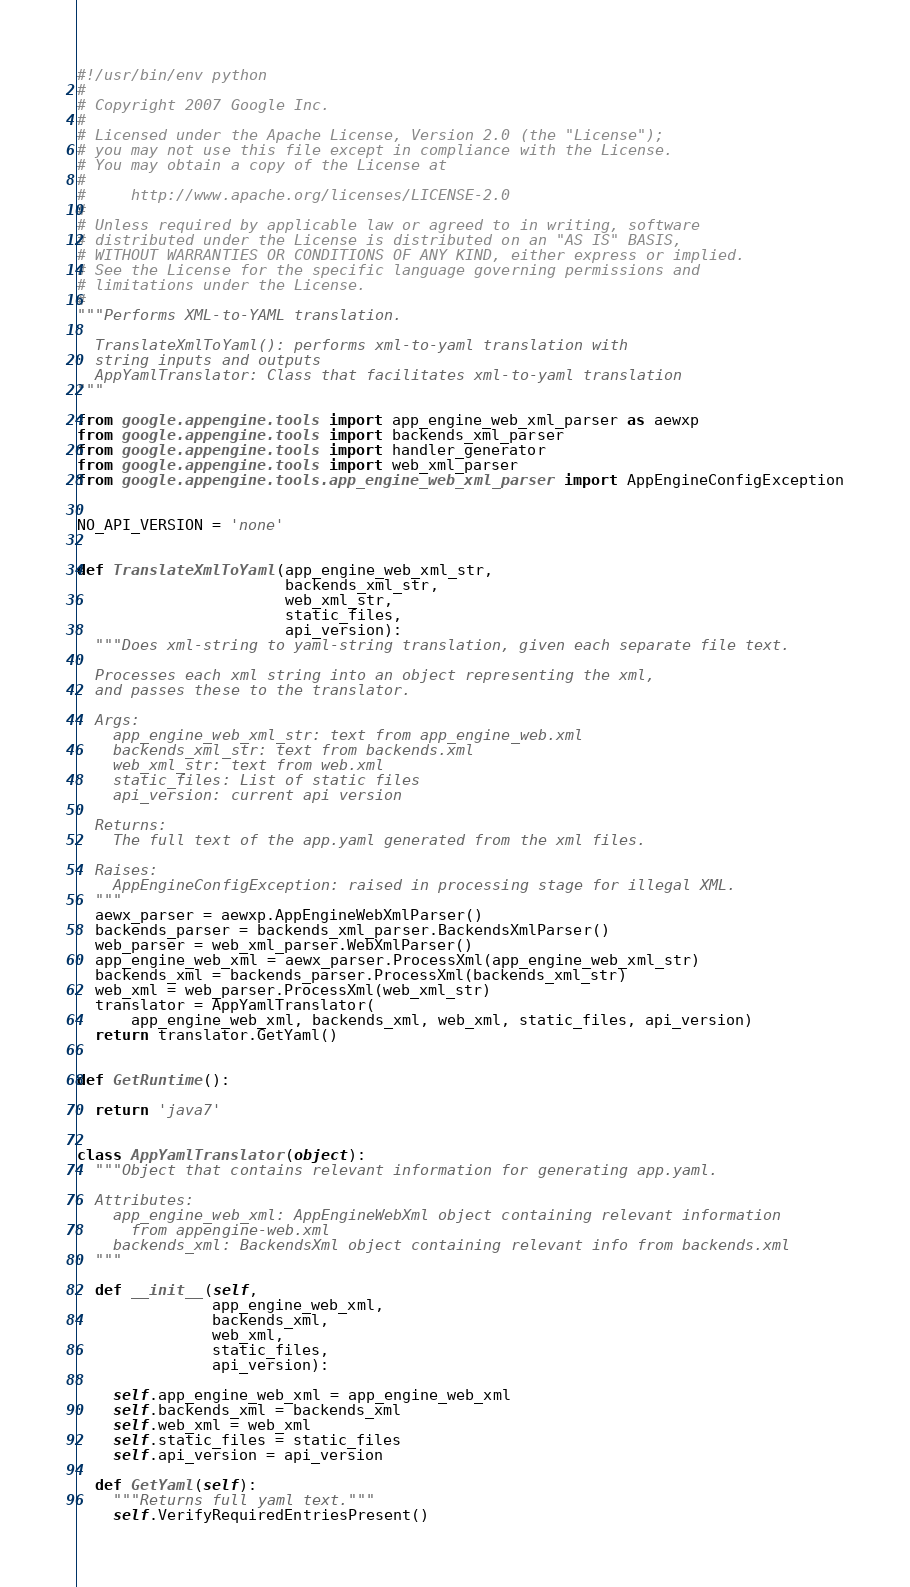Convert code to text. <code><loc_0><loc_0><loc_500><loc_500><_Python_>#!/usr/bin/env python
#
# Copyright 2007 Google Inc.
#
# Licensed under the Apache License, Version 2.0 (the "License");
# you may not use this file except in compliance with the License.
# You may obtain a copy of the License at
#
#     http://www.apache.org/licenses/LICENSE-2.0
#
# Unless required by applicable law or agreed to in writing, software
# distributed under the License is distributed on an "AS IS" BASIS,
# WITHOUT WARRANTIES OR CONDITIONS OF ANY KIND, either express or implied.
# See the License for the specific language governing permissions and
# limitations under the License.
#
"""Performs XML-to-YAML translation.

  TranslateXmlToYaml(): performs xml-to-yaml translation with
  string inputs and outputs
  AppYamlTranslator: Class that facilitates xml-to-yaml translation
"""

from google.appengine.tools import app_engine_web_xml_parser as aewxp
from google.appengine.tools import backends_xml_parser
from google.appengine.tools import handler_generator
from google.appengine.tools import web_xml_parser
from google.appengine.tools.app_engine_web_xml_parser import AppEngineConfigException


NO_API_VERSION = 'none'


def TranslateXmlToYaml(app_engine_web_xml_str,
                       backends_xml_str,
                       web_xml_str,
                       static_files,
                       api_version):
  """Does xml-string to yaml-string translation, given each separate file text.

  Processes each xml string into an object representing the xml,
  and passes these to the translator.

  Args:
    app_engine_web_xml_str: text from app_engine_web.xml
    backends_xml_str: text from backends.xml
    web_xml_str: text from web.xml
    static_files: List of static files
    api_version: current api version

  Returns:
    The full text of the app.yaml generated from the xml files.

  Raises:
    AppEngineConfigException: raised in processing stage for illegal XML.
  """
  aewx_parser = aewxp.AppEngineWebXmlParser()
  backends_parser = backends_xml_parser.BackendsXmlParser()
  web_parser = web_xml_parser.WebXmlParser()
  app_engine_web_xml = aewx_parser.ProcessXml(app_engine_web_xml_str)
  backends_xml = backends_parser.ProcessXml(backends_xml_str)
  web_xml = web_parser.ProcessXml(web_xml_str)
  translator = AppYamlTranslator(
      app_engine_web_xml, backends_xml, web_xml, static_files, api_version)
  return translator.GetYaml()


def GetRuntime():

  return 'java7'


class AppYamlTranslator(object):
  """Object that contains relevant information for generating app.yaml.

  Attributes:
    app_engine_web_xml: AppEngineWebXml object containing relevant information
      from appengine-web.xml
    backends_xml: BackendsXml object containing relevant info from backends.xml
  """

  def __init__(self,
               app_engine_web_xml,
               backends_xml,
               web_xml,
               static_files,
               api_version):

    self.app_engine_web_xml = app_engine_web_xml
    self.backends_xml = backends_xml
    self.web_xml = web_xml
    self.static_files = static_files
    self.api_version = api_version

  def GetYaml(self):
    """Returns full yaml text."""
    self.VerifyRequiredEntriesPresent()</code> 